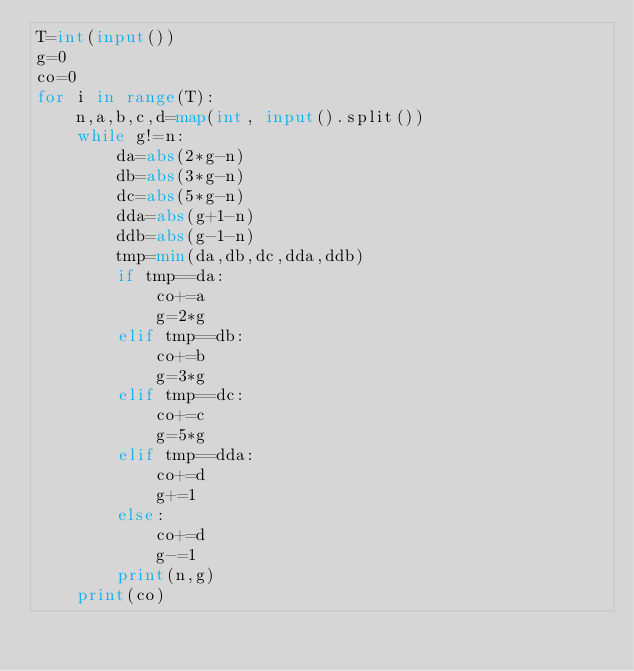<code> <loc_0><loc_0><loc_500><loc_500><_Python_>T=int(input())
g=0
co=0
for i in range(T):
    n,a,b,c,d=map(int, input().split())
    while g!=n:
        da=abs(2*g-n)
        db=abs(3*g-n)
        dc=abs(5*g-n)
        dda=abs(g+1-n)
        ddb=abs(g-1-n)
        tmp=min(da,db,dc,dda,ddb)
        if tmp==da:
            co+=a
            g=2*g
        elif tmp==db:
            co+=b
            g=3*g
        elif tmp==dc:
            co+=c
            g=5*g
        elif tmp==dda:
            co+=d
            g+=1
        else:
            co+=d
            g-=1
        print(n,g)
    print(co)
    
</code> 